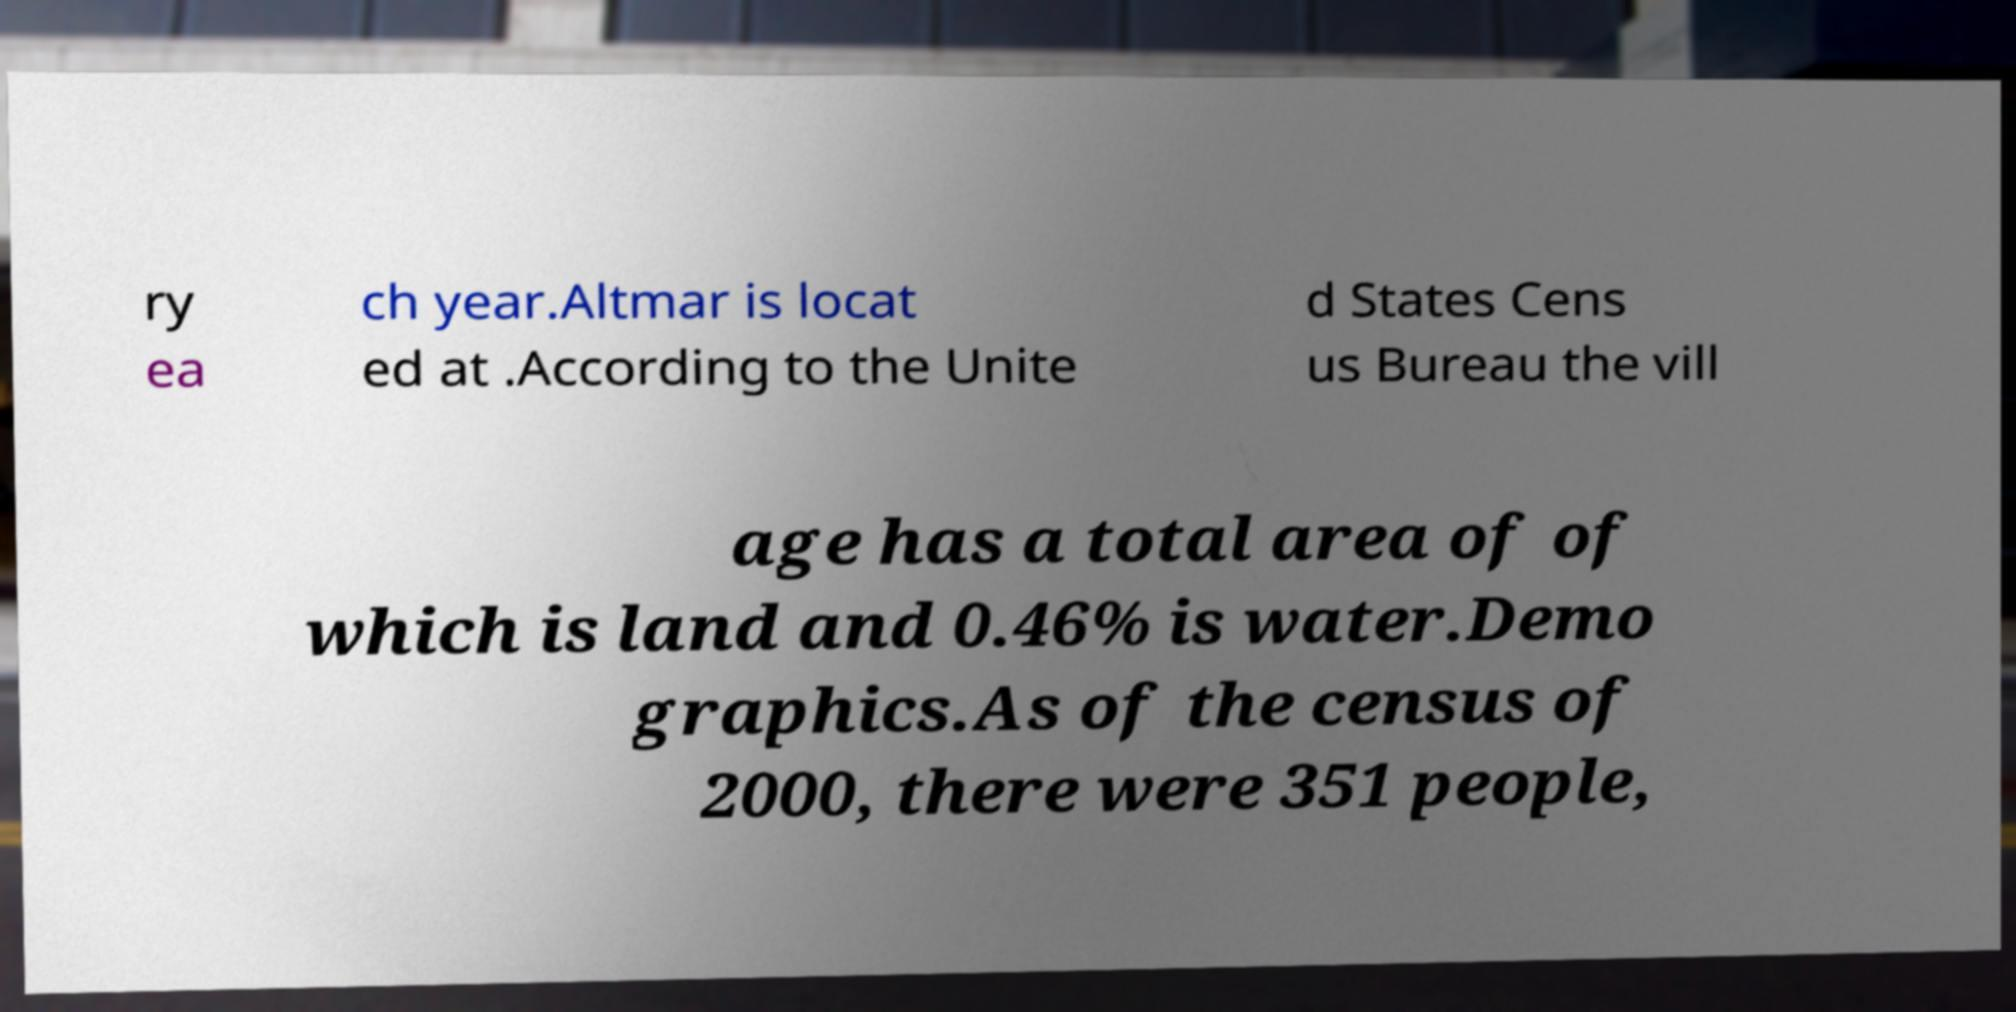What messages or text are displayed in this image? I need them in a readable, typed format. ry ea ch year.Altmar is locat ed at .According to the Unite d States Cens us Bureau the vill age has a total area of of which is land and 0.46% is water.Demo graphics.As of the census of 2000, there were 351 people, 